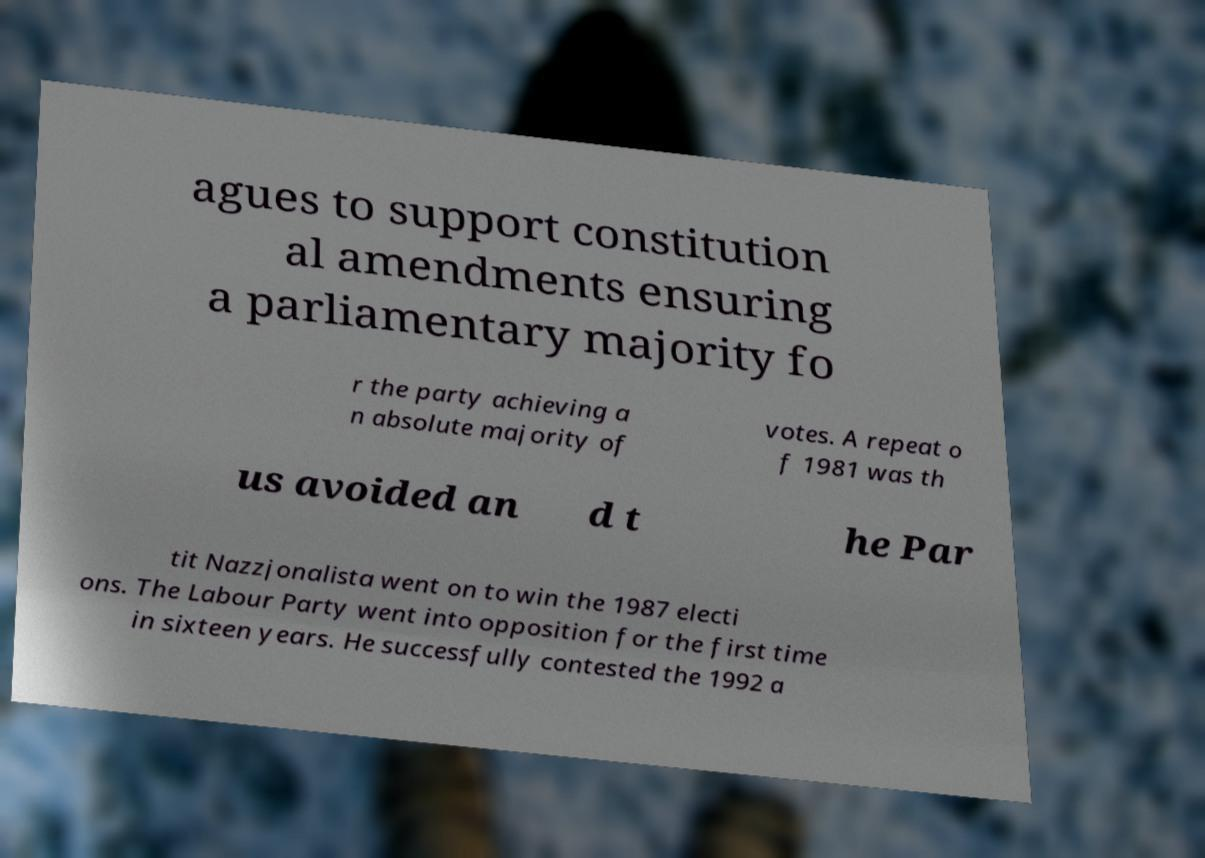Please identify and transcribe the text found in this image. agues to support constitution al amendments ensuring a parliamentary majority fo r the party achieving a n absolute majority of votes. A repeat o f 1981 was th us avoided an d t he Par tit Nazzjonalista went on to win the 1987 electi ons. The Labour Party went into opposition for the first time in sixteen years. He successfully contested the 1992 a 